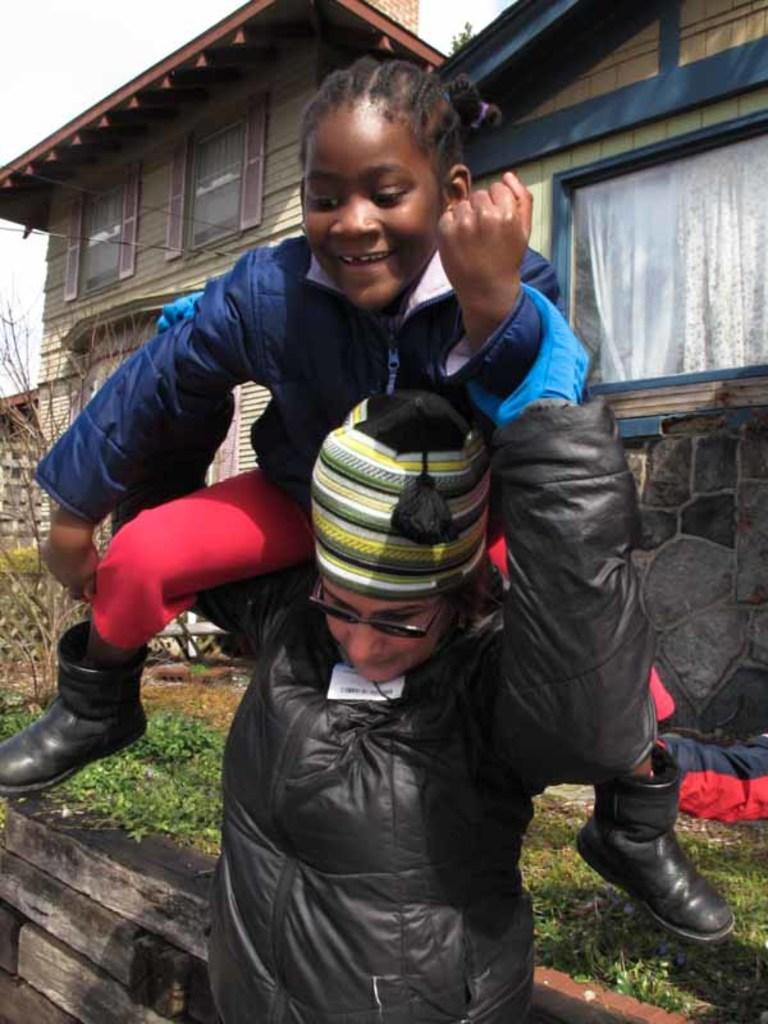How many people are in the image? There are two persons in the front of the image. What can be seen between the people and the buildings in the image? There are plants in the middle of the image. What type of structures are visible in the background of the image? There are buildings in the background of the image. What is visible at the top of the image? The sky is visible at the top of the image. Where is the playground located in the image? There is no playground present in the image. What type of test can be seen being conducted in the image? There is no test being conducted in the image. 